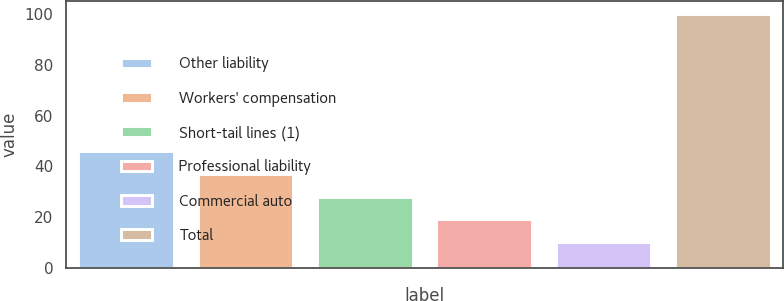Convert chart. <chart><loc_0><loc_0><loc_500><loc_500><bar_chart><fcel>Other liability<fcel>Workers' compensation<fcel>Short-tail lines (1)<fcel>Professional liability<fcel>Commercial auto<fcel>Total<nl><fcel>46.12<fcel>37.14<fcel>28.16<fcel>19.18<fcel>10.2<fcel>100<nl></chart> 